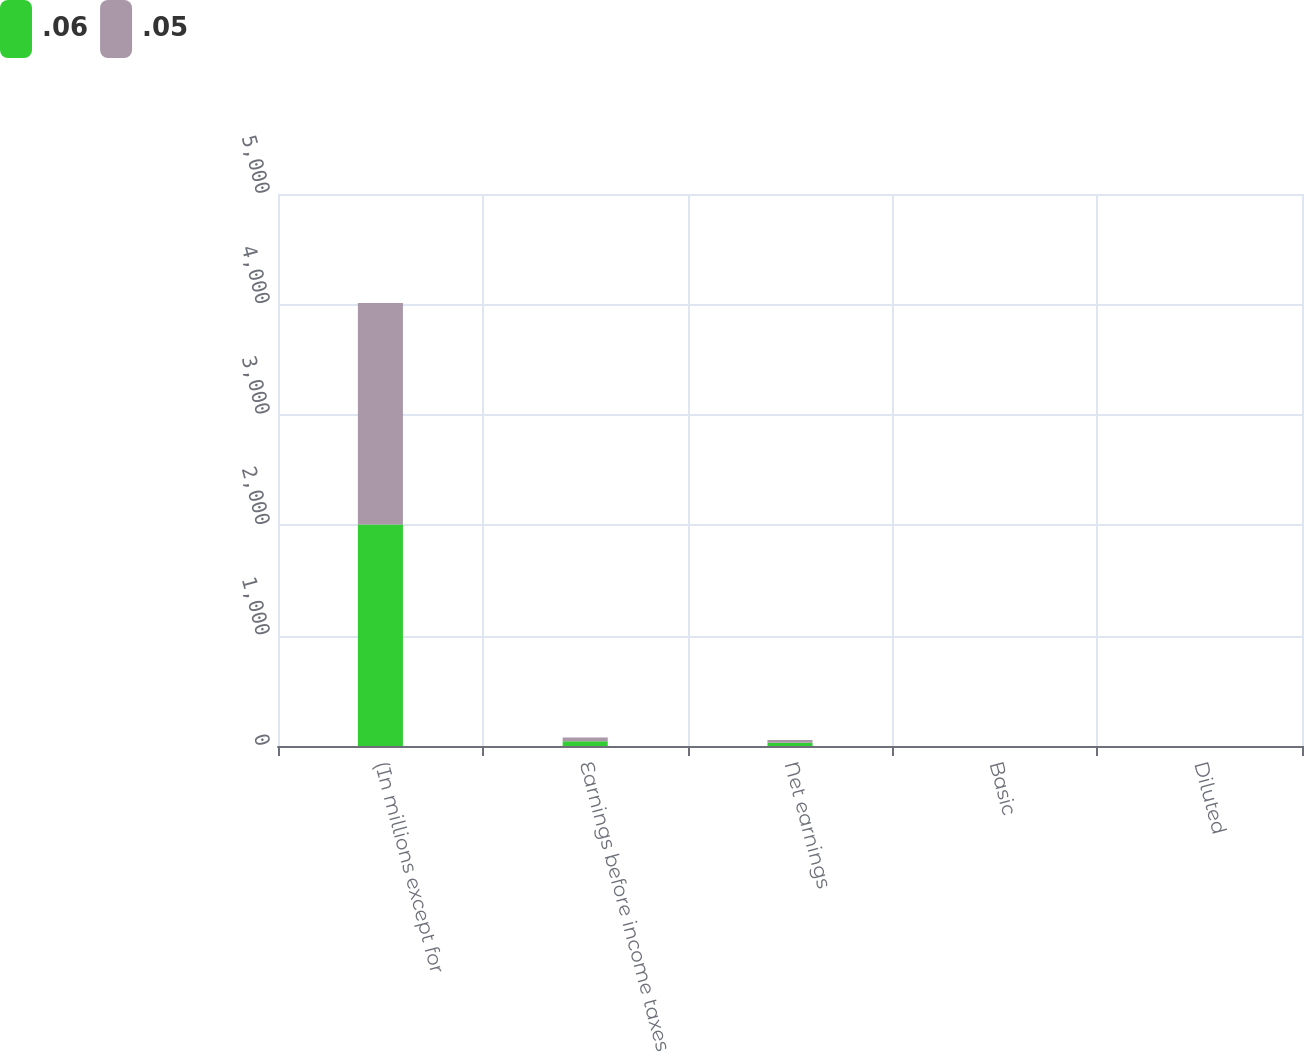<chart> <loc_0><loc_0><loc_500><loc_500><stacked_bar_chart><ecel><fcel>(In millions except for<fcel>Earnings before income taxes<fcel>Net earnings<fcel>Basic<fcel>Diluted<nl><fcel>0.06<fcel>2007<fcel>42<fcel>29<fcel>0.06<fcel>0.06<nl><fcel>0.05<fcel>2006<fcel>35<fcel>25<fcel>0.05<fcel>0.05<nl></chart> 